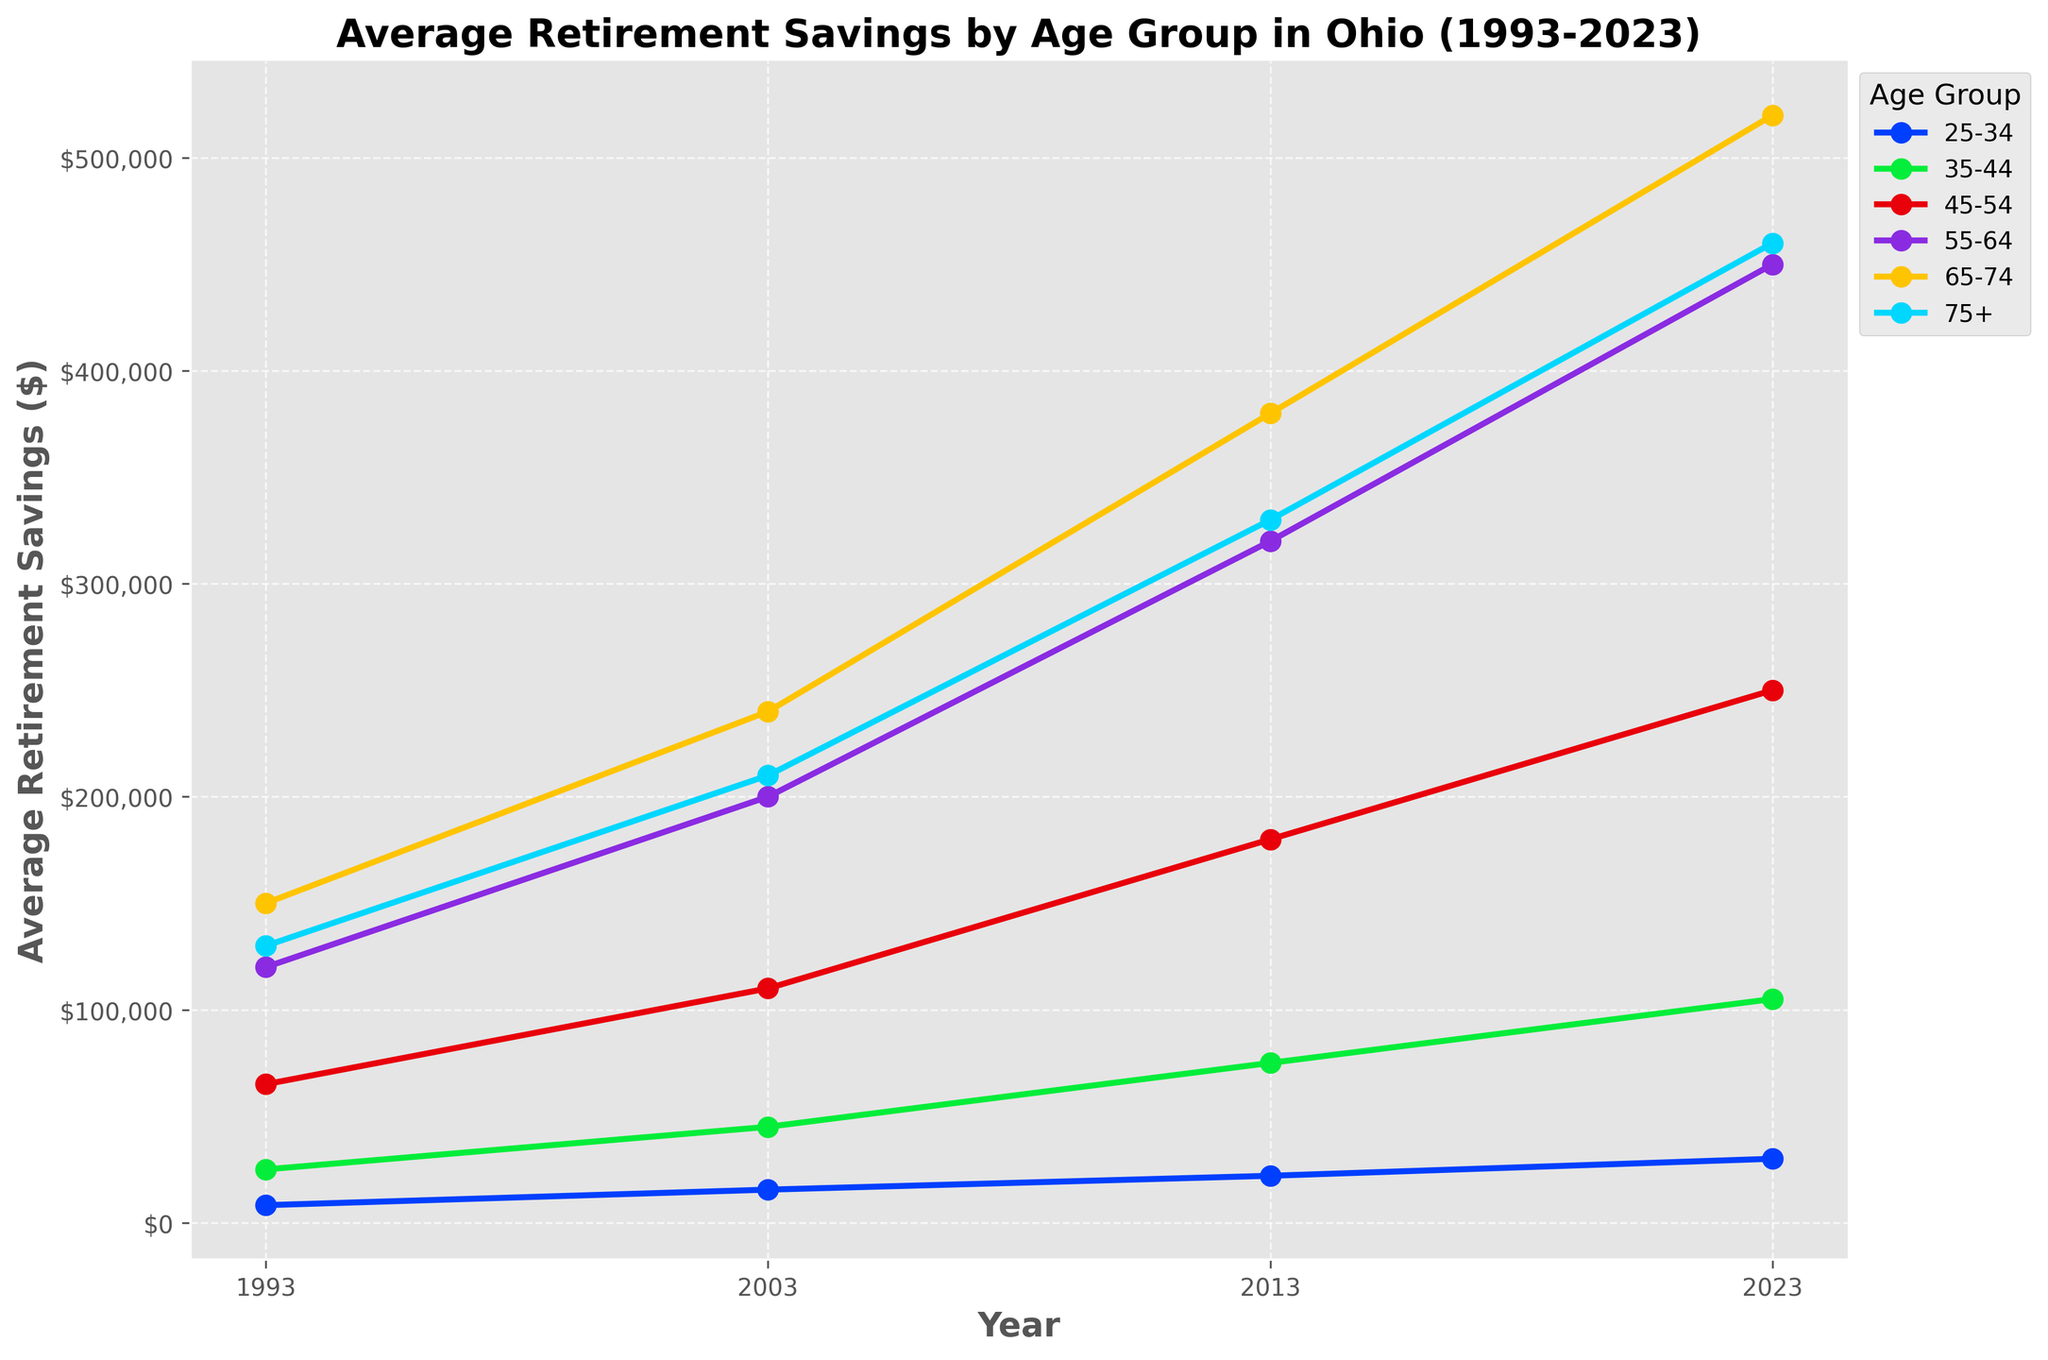What is the average retirement savings for those aged 55-64 in 2023? The value for the 55-64 age group in 2023 is directly labeled on the plot.
Answer: $450,000 Which age group has the highest retirement savings in 2023? Each line on the chart represents an age group. By looking at the 2023 values, the line representing the 65-74 age group is the highest.
Answer: 65-74 How did the retirement savings for the 45-54 age group change between 1993 and 2023? You can compare the 1993 and 2023 values by looking at the endpoints of the line for the 45-54 age group. The values are $65,000 in 1993 and $250,000 in 2023. So, the change is $250,000 - $65,000.
Answer: $185,000 increase Which age group had the smallest increase in retirement savings from 1993 to 2023? Calculate the increase for each age group from 1993 to 2023 and compare the results. The 25-34 group's increase is $30,000 - $8,200 = $21,800; the 35-44 group's increase is $105,000 - $25,000 = $80,000; the 45-54 group's increase is $250,000 - $65,000 = $185,000; the 55-64 group's increase is $450,000 - $120,000 = $330,000; the 65-74 group's increase is $520,000 - $150,000 = $370,000; and the 75+ group's increase is $460,000 - $130,000 = $330,000. The smallest increase is for the 25-34 age group.
Answer: 25-34 By how much did the retirement savings of the 75+ age group increase between 2013 and 2023? The value for the 75+ age group in 2013 is $330,000 and in 2023 it is $460,000. The increase is $460,000 - $330,000.
Answer: $130,000 Which year shows the smallest gap in retirement savings between the 35-44 and 65-74 age groups, and what is the value of that gap? To find this, calculate the difference in savings between the 35-44 and 65-74 age groups for each year. In 1993, the gap is $150,000 - $25,000 = $125,000; in 2003, the gap is $240,000 - $45,000 = $195,000; in 2013, the gap is $380,000 - $75,000 = $305,000; in 2023, the gap is $520,000 - $105,000 = $415,000. The smallest gap is in 1993.
Answer: 1993, $125,000 How much more did the 65-74 age group save in 2003 compared to the 25-34 age group? The savings for the 65-74 age group in 2003 is $240,000, and for the 25-34 age group, it is $15,500. The difference is $240,000 - $15,500.
Answer: $224,500 What is the trend in retirement savings for the 25-34 age group over the past 30 years? Observe the 25-34 age group's line over time. It consistently increases from $8,200 in 1993 to $30,000 in 2023.
Answer: Consistent increase Comparing the savings increase from 2003 to 2023, which age group had the largest percentage increase? Calculate the percentage increase for each age group from 2003 to 2023: for 25-34: ($30,000 - $15,500) / $15,500 * 100 ≈ 93.5%, for 35-44: ($105,000 - $45,000) / $45,000 * 100 ≈ 133.3%, for 45-54: ($250,000 - $110,000) / $110,000 * 100 ≈ 127.3%, for 55-64: ($450,000 - $200,000) / $200,000 * 100 = 125%, for 65-74: ($520,000 - $240,000) / $240,000 * 100 ≈ 116.7%, and for 75+: ($460,000 - $210,000) / $210,000 * 100 ≈ 119%. The 35-44 age group has the largest percentage increase.
Answer: 35-44, 133.3% 